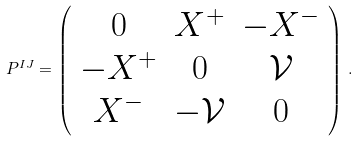<formula> <loc_0><loc_0><loc_500><loc_500>P ^ { I J } = \left ( \begin{array} { c c c } 0 & X ^ { + } & - X ^ { - } \\ - X ^ { + } & 0 & \mathcal { V } \\ X ^ { - } & - \mathcal { V } & 0 \end{array} \right ) \, .</formula> 